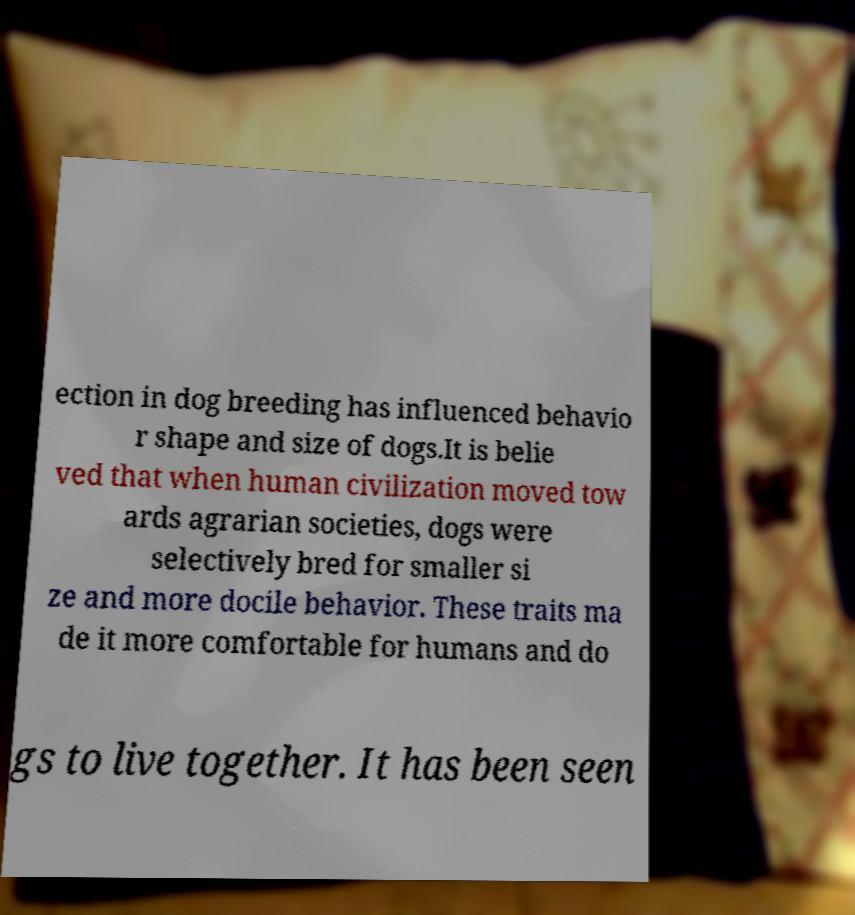Please identify and transcribe the text found in this image. ection in dog breeding has influenced behavio r shape and size of dogs.It is belie ved that when human civilization moved tow ards agrarian societies, dogs were selectively bred for smaller si ze and more docile behavior. These traits ma de it more comfortable for humans and do gs to live together. It has been seen 